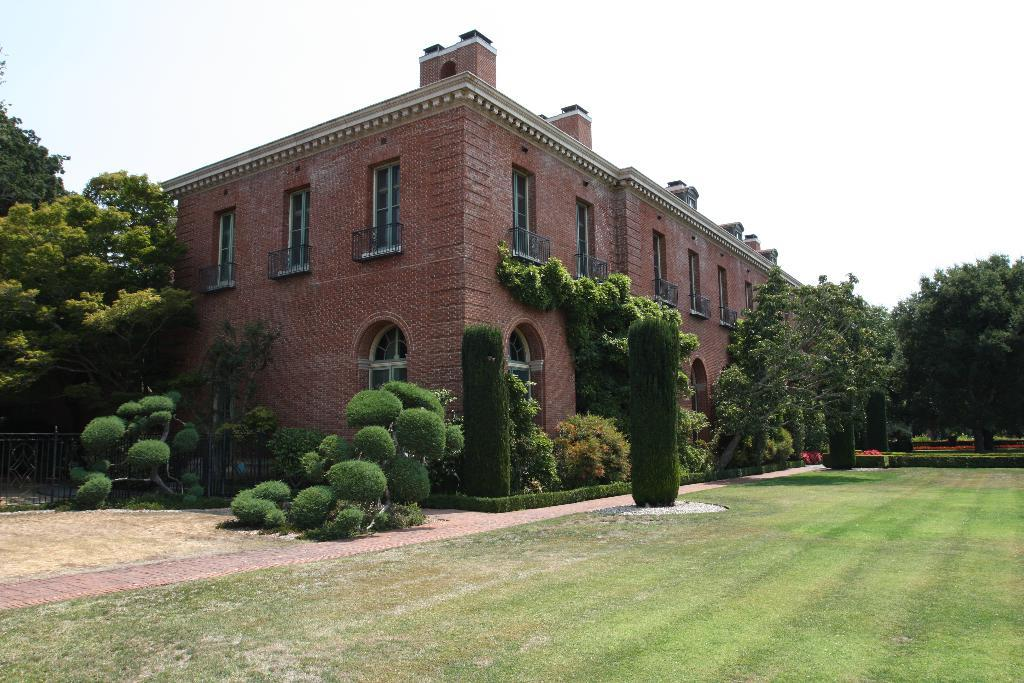What type of vegetation is present in the image? There is grass and plants in the image. What can be seen in the background of the image? There is a building, trees, and the sky visible in the background of the image. How many pizzas are being carried by the creature in the image? There is no creature or pizzas present in the image. What type of carriage can be seen in the image? There is no carriage present in the image. 